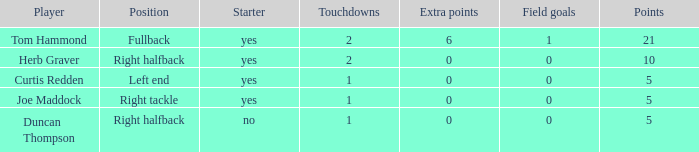What are the maximum supplementary points for precise right tackle? 0.0. 